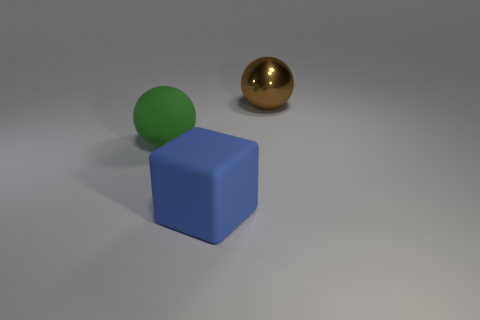Does the large object left of the large rubber cube have the same shape as the large shiny thing? The object to the left of the large rubber cube, which appears to be a sphere, does not share the same shape as the large shiny object, which is spherical as well. Both the green sphere and the golden sphere have round geometries in contrast to the cubic shape of the blue object. 